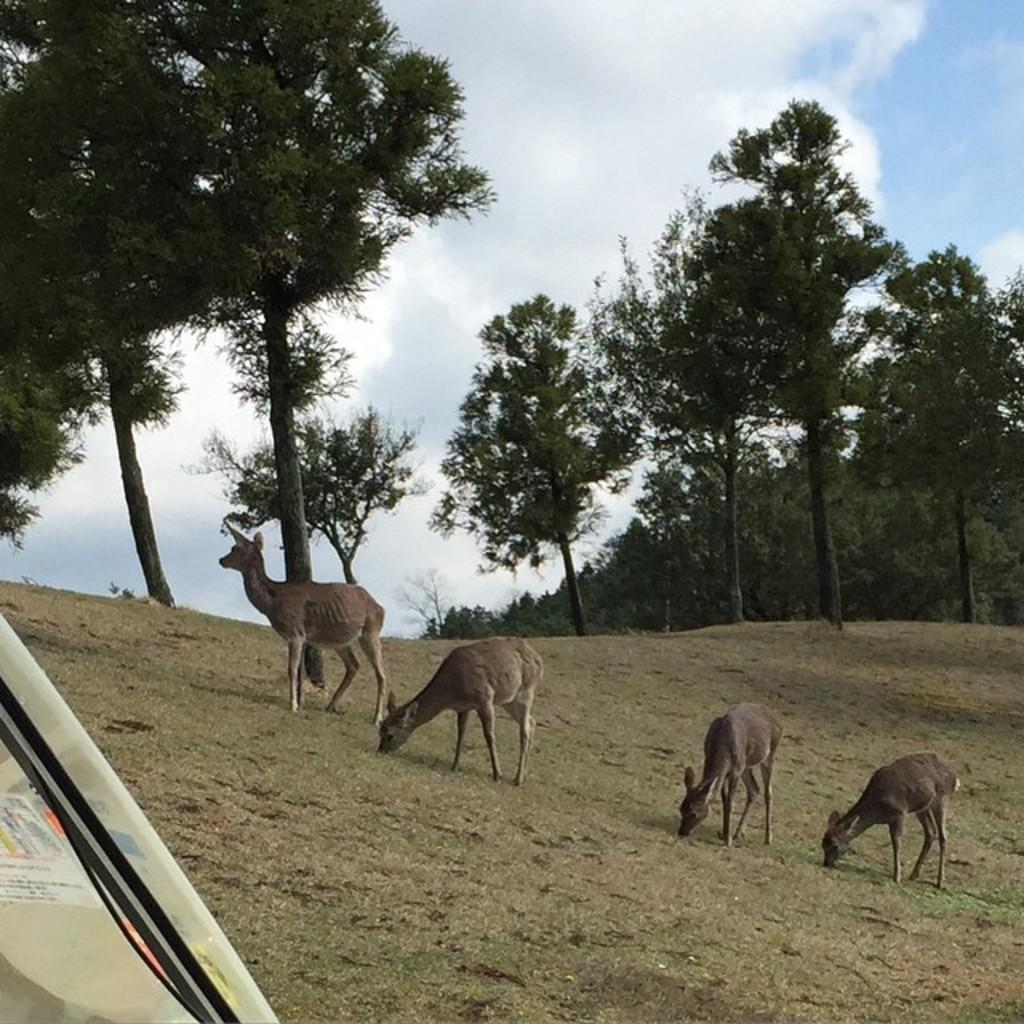What types of living organisms can be seen in the image? There are animals in the image. What can be seen beneath the animals in the image? The ground is visible in the image. What type of vegetation is present in the image? There are trees in the image. What is visible above the animals in the image? The sky is visible in the image, and clouds are present in the sky. Where is the tent located in the image? The tent is on the left side of the image. What type of pie is being served by the fairies in the image? There are no fairies or pies present in the image. What color is the eye of the animal in the image? The image does not show any close-up of an animal's eye, so it is not possible to determine the color of the eye. 